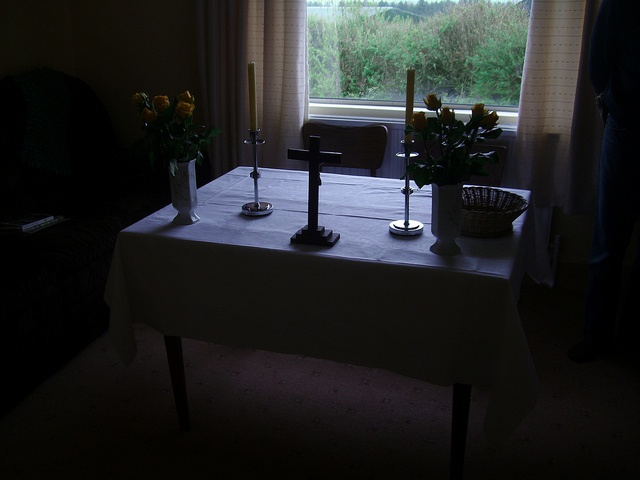Describe the objects in this image and their specific colors. I can see dining table in black, darkgray, and gray tones, potted plant in black, gray, and navy tones, potted plant in black, gray, navy, and darkblue tones, chair in black, navy, and gray tones, and bowl in black and gray tones in this image. 